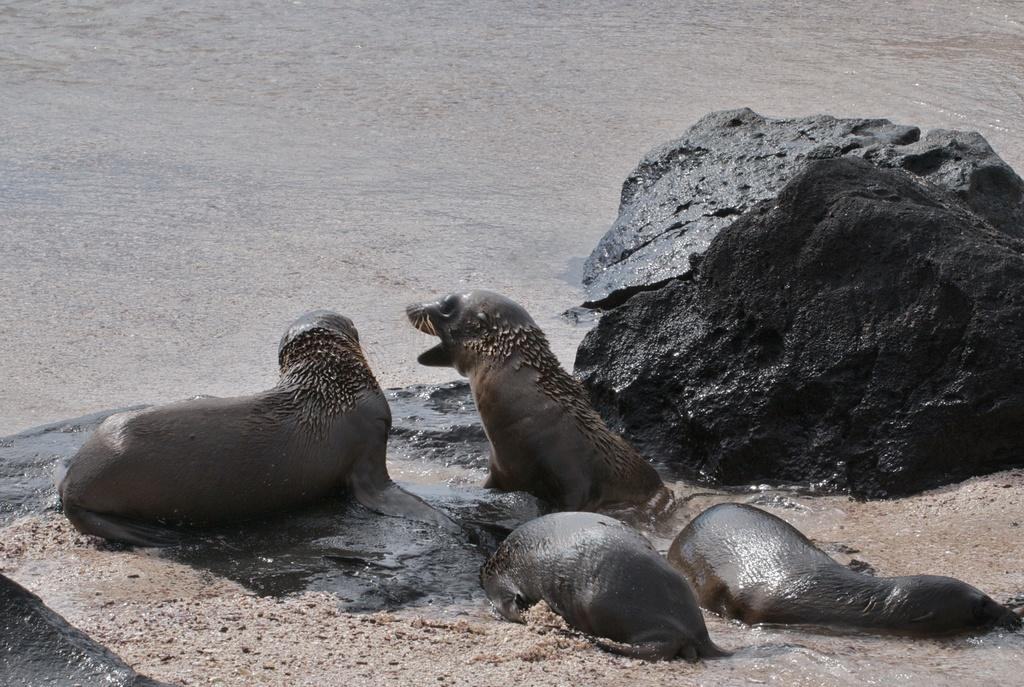What type of natural environment is depicted in the image? There is a sea in the image. What geological feature can be seen in the image? There is a rock in the image. What type of animals can be seen in the image? There are aquatic animals in the image. What type of thread is being used to sew the oil in the image? There is no thread or oil present in the image; it features a sea and a rock with aquatic animals. 